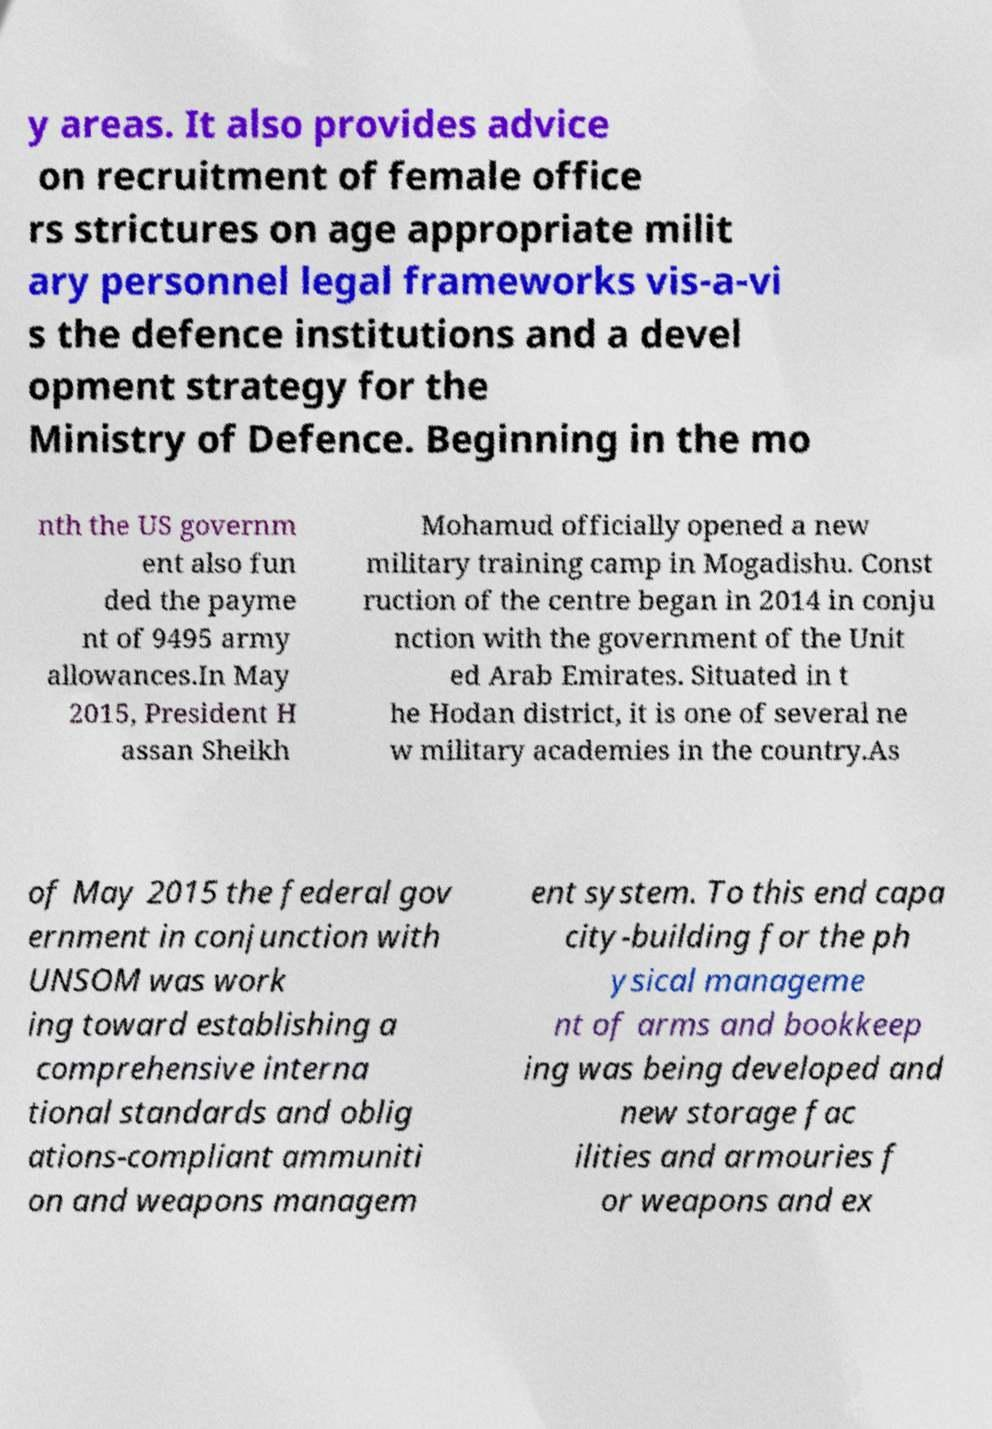Can you accurately transcribe the text from the provided image for me? y areas. It also provides advice on recruitment of female office rs strictures on age appropriate milit ary personnel legal frameworks vis-a-vi s the defence institutions and a devel opment strategy for the Ministry of Defence. Beginning in the mo nth the US governm ent also fun ded the payme nt of 9495 army allowances.In May 2015, President H assan Sheikh Mohamud officially opened a new military training camp in Mogadishu. Const ruction of the centre began in 2014 in conju nction with the government of the Unit ed Arab Emirates. Situated in t he Hodan district, it is one of several ne w military academies in the country.As of May 2015 the federal gov ernment in conjunction with UNSOM was work ing toward establishing a comprehensive interna tional standards and oblig ations-compliant ammuniti on and weapons managem ent system. To this end capa city-building for the ph ysical manageme nt of arms and bookkeep ing was being developed and new storage fac ilities and armouries f or weapons and ex 